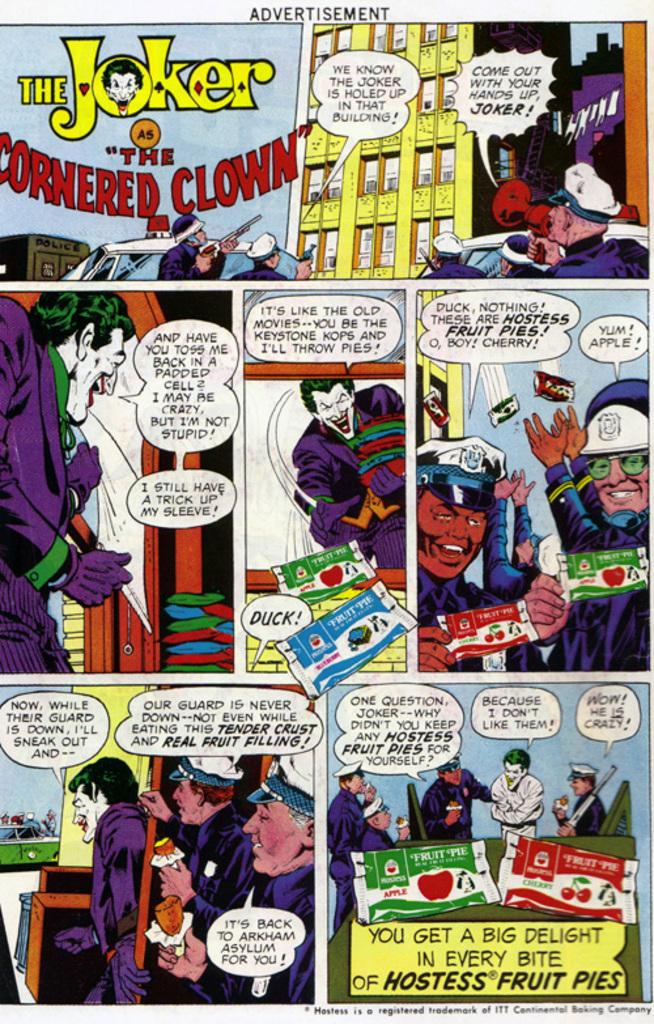Which batman character is the title of this piece about?
Your answer should be compact. The joker. What kind of fruit pies are these?
Your response must be concise. Hostess. 